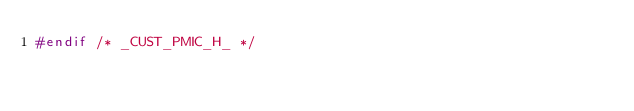Convert code to text. <code><loc_0><loc_0><loc_500><loc_500><_C_>#endif /* _CUST_PMIC_H_ */ 
</code> 